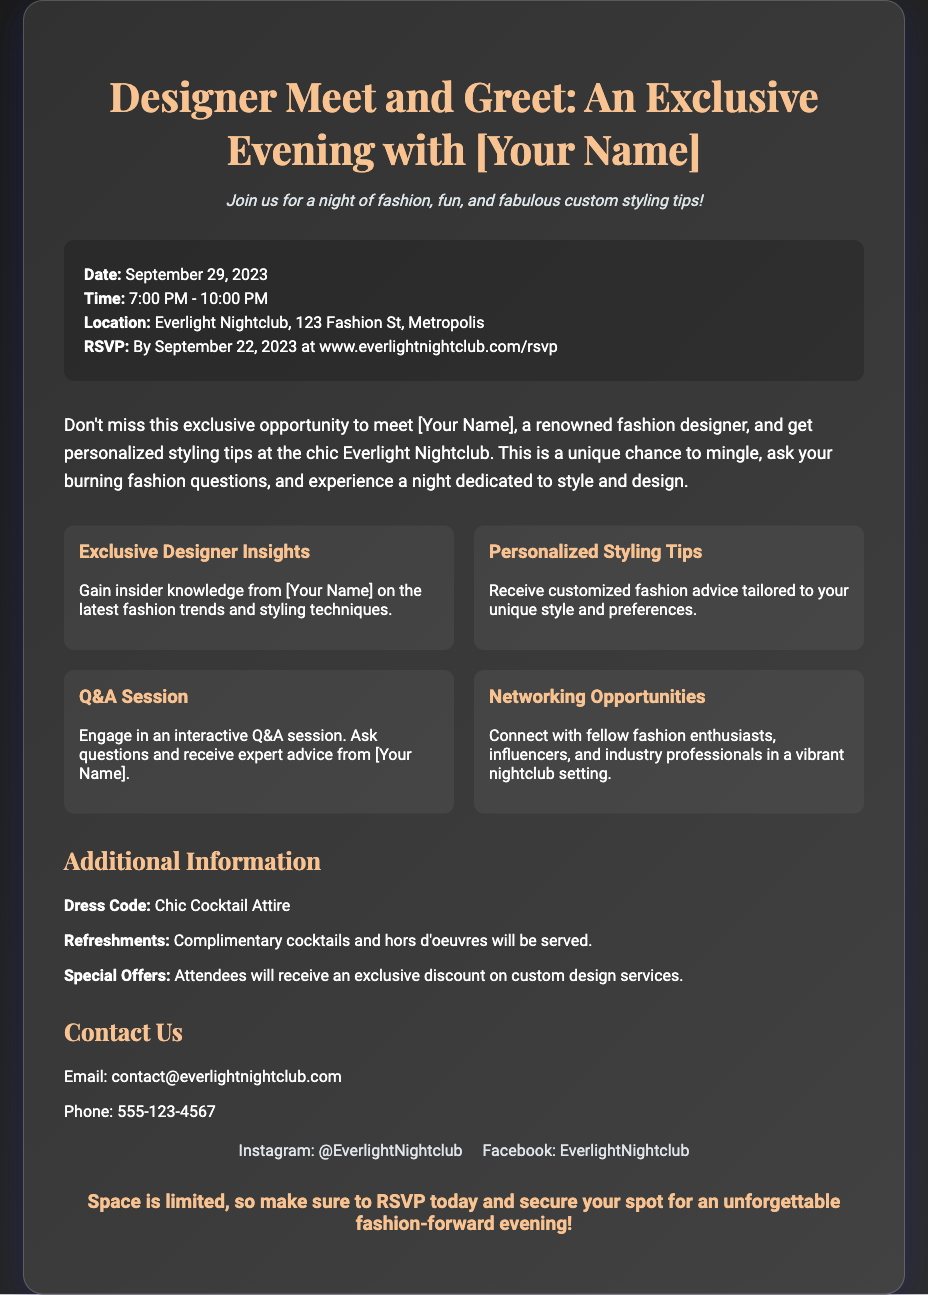what is the date of the event? The date of the event is clearly stated in the document under the event details section.
Answer: September 29, 2023 what time does the event start? The start time of the event is mentioned in the event details section.
Answer: 7:00 PM where is the event taking place? The location of the event is specified in the event details.
Answer: Everlight Nightclub, 123 Fashion St, Metropolis who is hosting the Meet and Greet? The flyer indicates that a renowned fashion designer will be hosting the event, mentioning their name in a few places.
Answer: [Your Name] what is one of the highlights of the event? The highlights section lists several key aspects of the event, including exclusive insights and personal styling tips.
Answer: Exclusive Designer Insights what is the dress code for the evening? The dress code is explicitly mentioned in the additional information section of the flyer.
Answer: Chic Cocktail Attire by what date should attendees RSVP? The RSVP date is provided in the event details section of the flyer.
Answer: September 22, 2023 what kind of refreshments will be served? The type of refreshments is specified in the additional information part of the document.
Answer: Complimentary cocktails and hors d'oeuvres why is the event considered an exclusive opportunity? The introductory paragraph describes the unique aspects of the event, emphasizing personal interactions and styling tips with the designer.
Answer: Personalized styling tips 